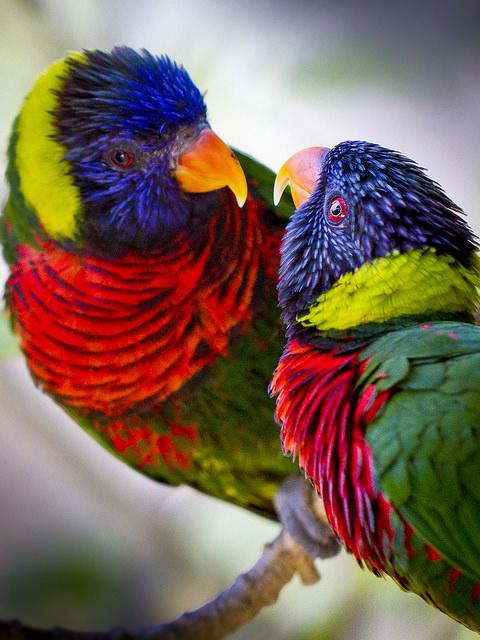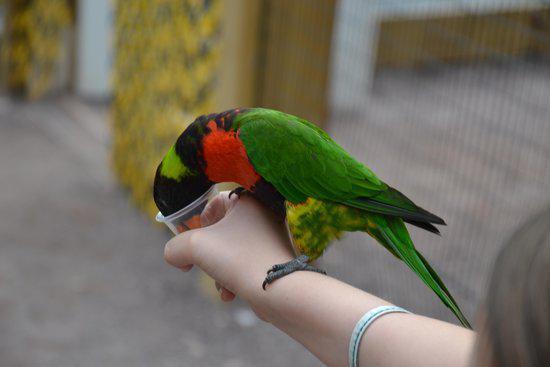The first image is the image on the left, the second image is the image on the right. For the images shown, is this caption "In at least one of the pictures, there are two birds that are both the same color." true? Answer yes or no. Yes. The first image is the image on the left, the second image is the image on the right. Assess this claim about the two images: "There are three birds, two in the left image and one on the right.". Correct or not? Answer yes or no. Yes. 